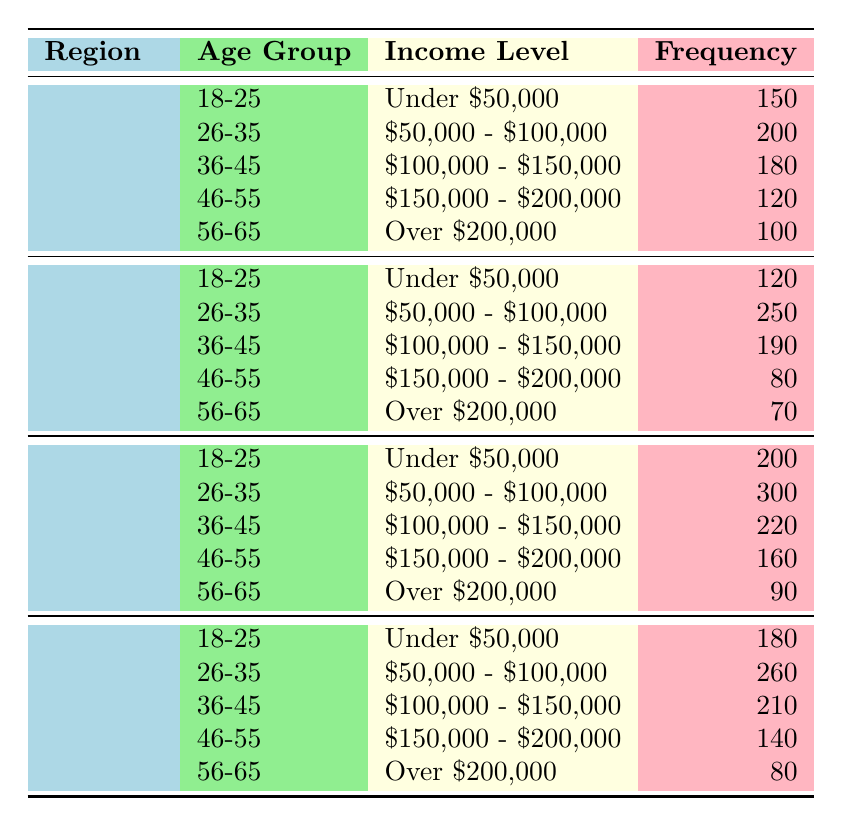What is the total frequency of homebuyers aged 26-35 in the South region? The South region has two age groups (26-35) with the corresponding frequencies. For the 26-35 age group, the frequency is 300. So, the total frequency for this age group in the South is simply equal to 300.
Answer: 300 How many homebuyers aged 36-45 from the Midwest have an income level of $100,000 - $150,000? From the table, looking specifically at the Midwest section, the frequency listed for those aged 36-45 with an income of $100,000 - $150,000 is 190.
Answer: 190 Is there a higher frequency of homebuyers aged 18-25 in the Northeast or the Midwest? In the Northeast, the frequency of homebuyers aged 18-25 is 150, while in the Midwest, the frequency is 120. Comparing these numbers shows that the Northeast has a higher frequency of 150 compared to the 120 in the Midwest.
Answer: Yes What is the average frequency of homebuyers aged 56-65 across all regions? To find the average frequency, we add the frequencies for the 56-65 age group: Northeast (100) + Midwest (70) + South (90) + West (80) = 340. The total number of regions is 4. Thus, the average frequency for this age group is 340 / 4 = 85.
Answer: 85 In which region do homebuyers aged 26-35 have the highest frequency, and what is that frequency? Checking the 26-35 age group across all regions: Northeast (200), Midwest (250), South (300), West (260). The highest is in the South with a frequency of 300.
Answer: South, 300 What is the total frequency of homebuyers earning over $200,000 in the Midwest and South combined? From the table, the frequencies for homebuyers earning over $200,000 are: Midwest (70) and South (90). Adding these together, 70 + 90 = 160, results in a total frequency of 160.
Answer: 160 Are there more homebuyers aged 46-55 in the Northeast or the West region? For the 46-55 age group, the Northeast has a frequency of 120 and the West has a frequency of 140. Since 140 is greater than 120, there are more homebuyers in the West.
Answer: West What is the difference in frequency between the highest and lowest income groups for the 18-25 age category in all regions? In the 18-25 age group: the highest frequency for "Under $50,000" (South with 200) and the lowest frequency for "Over $200,000" (West with 180). The difference is 200 - 150 = 50.
Answer: 50 